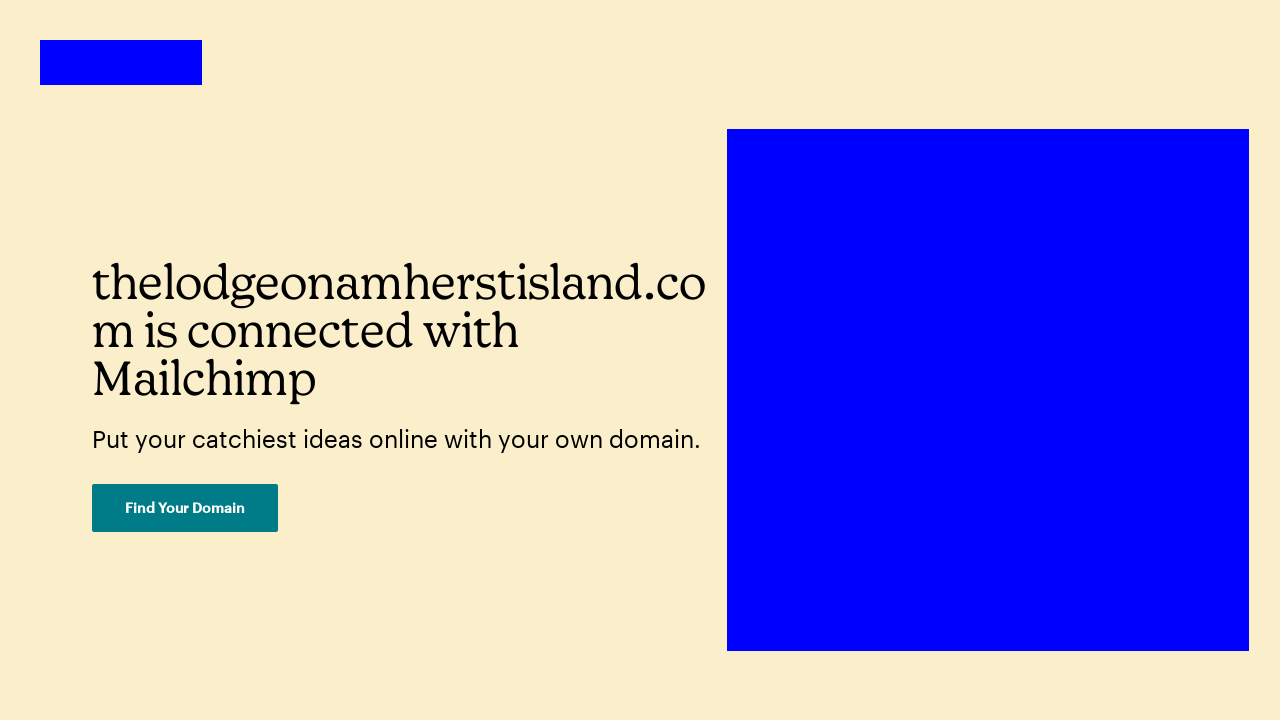What is the primary color used in the background of this web page? The primary color used in the background of this web page is a pale cream color, specifically noted in the CSS as #FBEECA. 